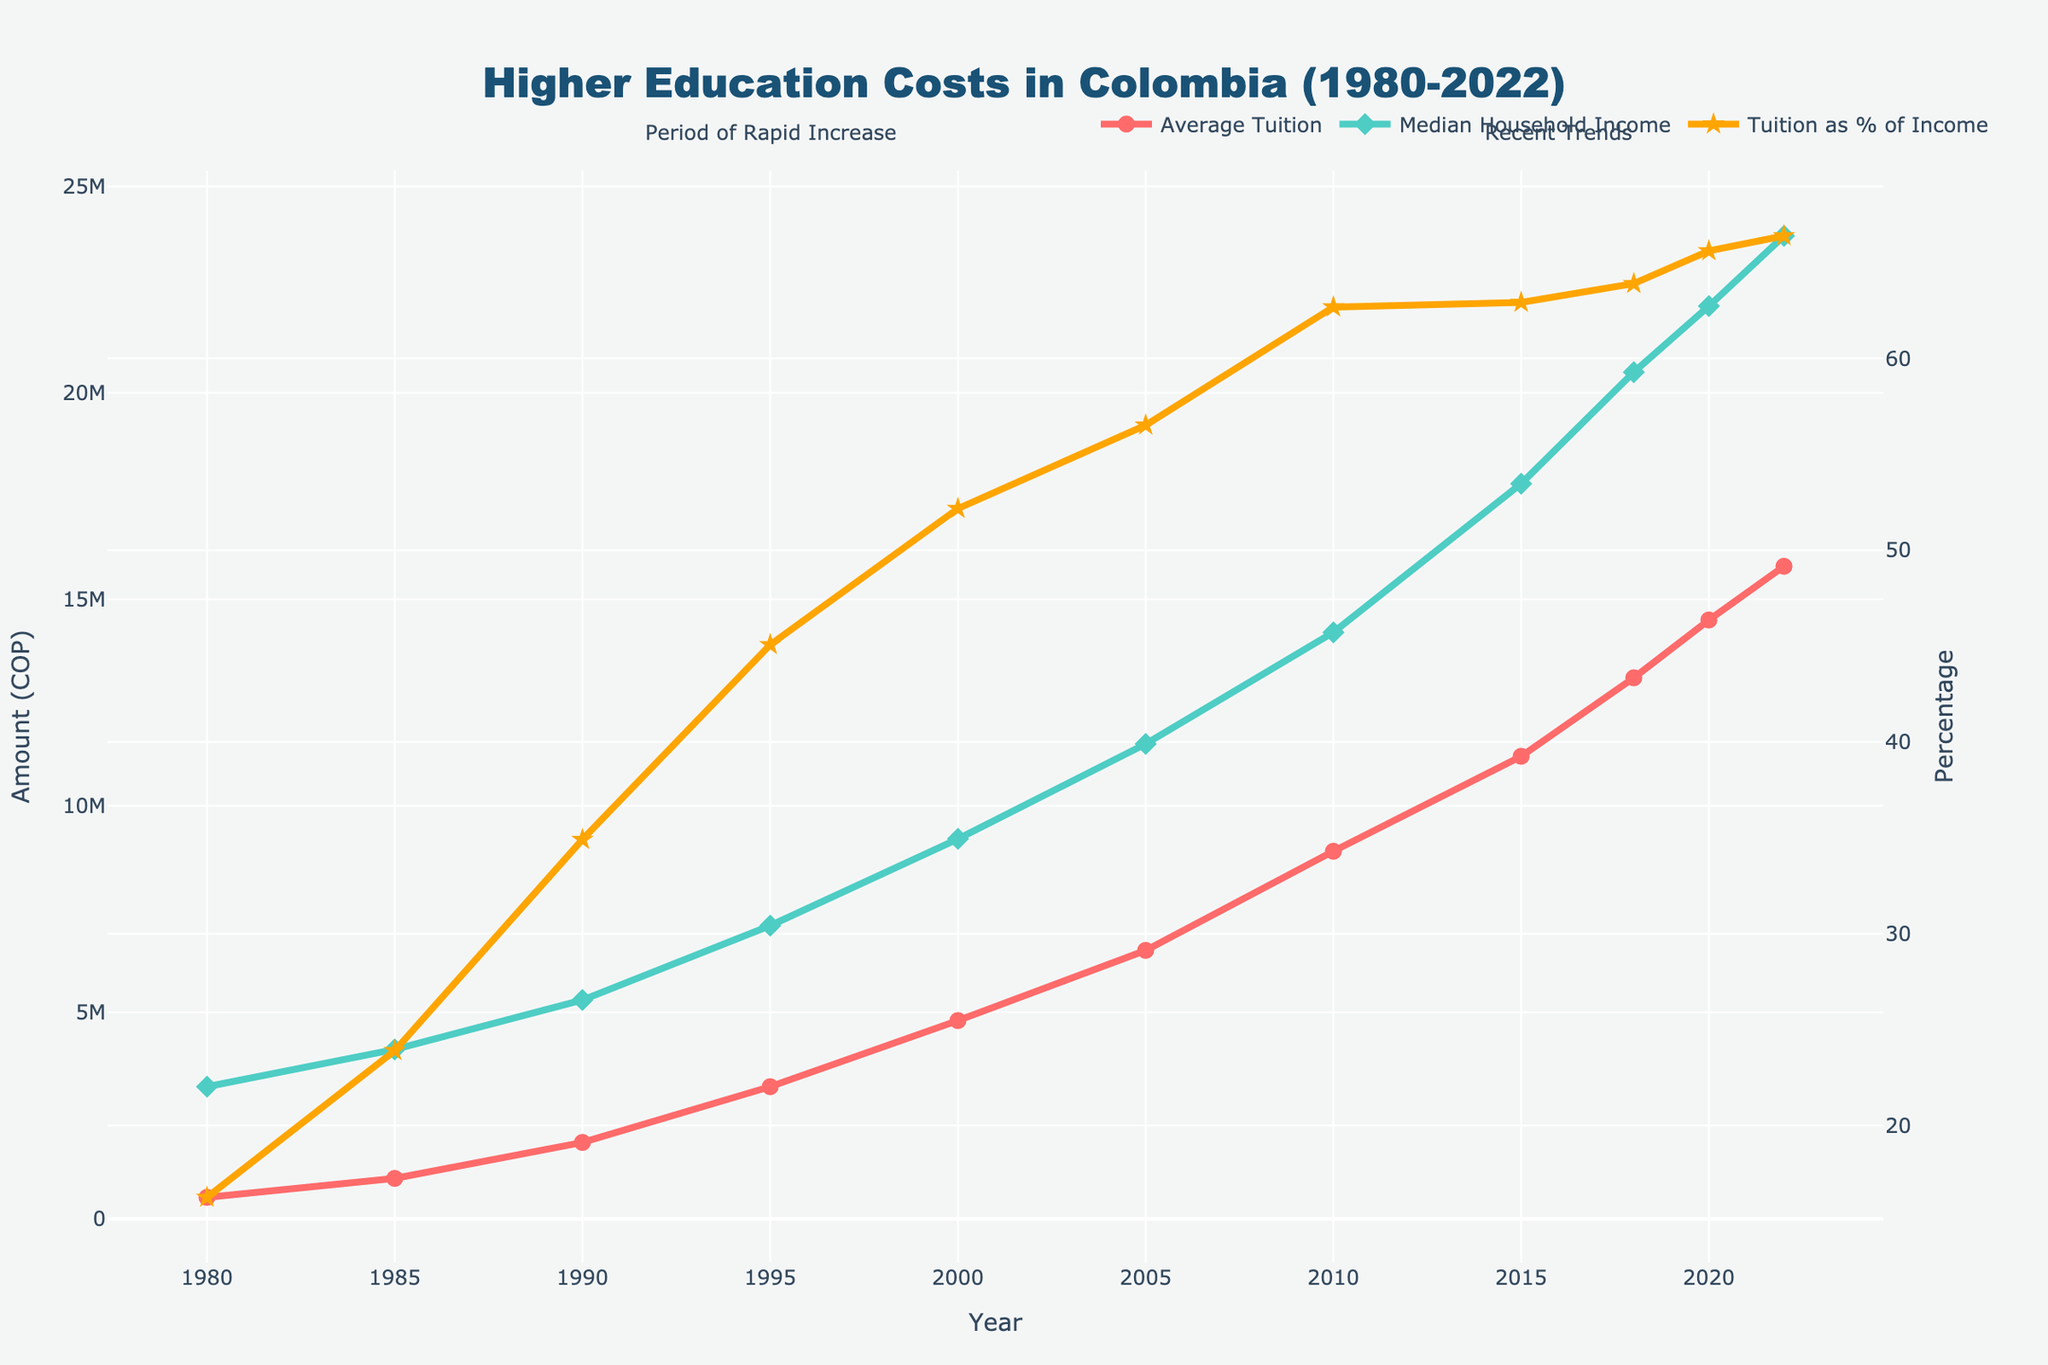Which year saw the highest average tuition fees? By looking at the line representing average tuition fees, the peak value reached is in 2022.
Answer: 2022 How did the Median Household Income change from 2000 to 2020? By observing the green line for Median Household Income, it increased from 9,200,000 COP in 2000 to 22,100,000 COP in 2020. The change is calculated as 22,100,000 - 9,200,000 = 12,900,000 COP.
Answer: 12,900,000 COP What trend can be observed in the relationship between Average Tuition and Median Household Income from 1990 to 2000? From the plot, both the average tuition and median household income increased, but the tuition grew at a faster rate. This is evident as the gap between the red and green lines widens during this period.
Answer: Tuition grew faster Which period is highlighted as having a "Rapid Increase"? The gray shaded area from 1990 to 2000 is annotated as the "Period of Rapid Increase."
Answer: 1990 to 2000 When did Tuition as a % of Income reach its highest value? By observing the orange line for "Tuition as % of Income," the highest value occurs in 2022.
Answer: 2022 What is the approximate percentage increase in Average Tuition Fees from 1980 to 2022? The average tuition in 1980 was 520,000 COP and in 2022 it was 15,800,000 COP. The percentage increase is calculated as [(15,800,000 - 520,000) / 520,000] * 100 = 2938.46%.
Answer: 2938.46% Compare the trends of Average Tuition Fees and Tuition as % of Income between 2015 and 2022. From the plot, both metrics are increasing, but "Tuition as % of Income" (orange line) shows a sharper increase compared to average tuition fees (red line) during this period.
Answer: Sharper increase for % of Income In which year did the Median Household Income first surpass 10,000,000 COP? The green line for Median Household Income first surpasses 10,000,000 COP in the year 2005.
Answer: 2005 What is the significance of the periods from 1990-2000 and 2010-2022 denoted in the figure? The gray shaded areas mark significant periods: 1990-2000 as "Period of Rapid Increase" and 2010-2022 marked as "Recent Trends," indicating notable trends in tuition fees and household income.
Answer: Significant periods highlighted 